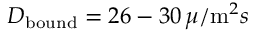Convert formula to latex. <formula><loc_0><loc_0><loc_500><loc_500>D _ { b o u n d } = 2 6 - 3 0 \, \mu / m ^ { 2 } s</formula> 